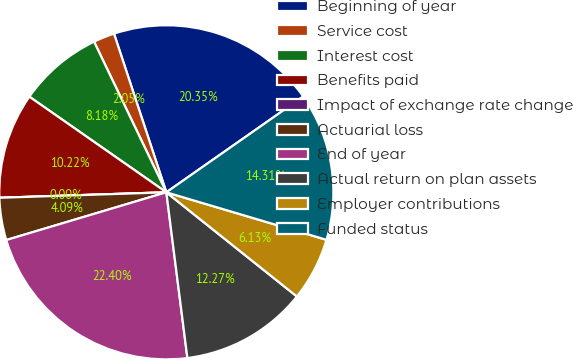Convert chart. <chart><loc_0><loc_0><loc_500><loc_500><pie_chart><fcel>Beginning of year<fcel>Service cost<fcel>Interest cost<fcel>Benefits paid<fcel>Impact of exchange rate change<fcel>Actuarial loss<fcel>End of year<fcel>Actual return on plan assets<fcel>Employer contributions<fcel>Funded status<nl><fcel>20.35%<fcel>2.05%<fcel>8.18%<fcel>10.22%<fcel>0.0%<fcel>4.09%<fcel>22.4%<fcel>12.27%<fcel>6.13%<fcel>14.31%<nl></chart> 